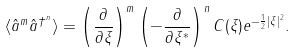Convert formula to latex. <formula><loc_0><loc_0><loc_500><loc_500>\langle \hat { a } ^ { m } \hat { a } ^ { \dag ^ { n } } \rangle = \left ( \frac { \partial } { \partial \xi } \right ) ^ { m } \left ( - \frac { \partial } { \partial \xi ^ { * } } \right ) ^ { n } C ( \xi ) e ^ { - \frac { 1 } { 2 } | \xi | ^ { 2 } } .</formula> 